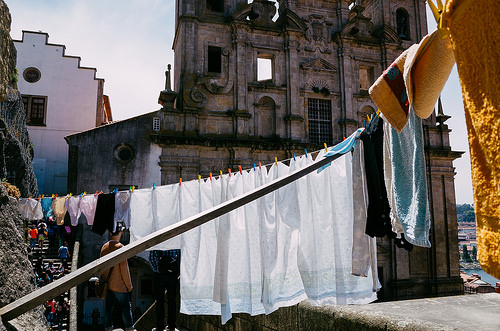<image>
Is the underpants next to the towel? No. The underpants is not positioned next to the towel. They are located in different areas of the scene. 